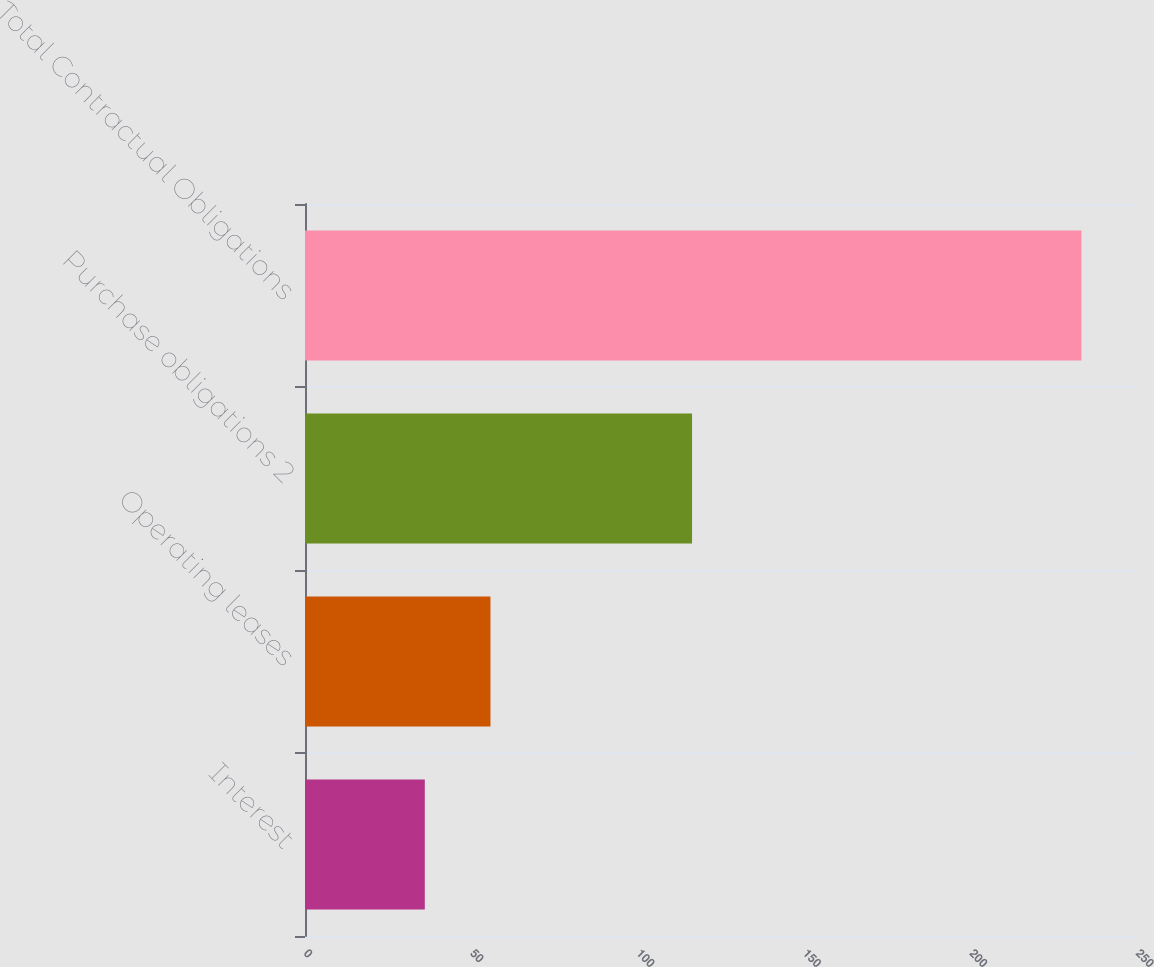Convert chart. <chart><loc_0><loc_0><loc_500><loc_500><bar_chart><fcel>Interest<fcel>Operating leases<fcel>Purchase obligations 2<fcel>Total Contractual Obligations<nl><fcel>36<fcel>55.73<fcel>116.3<fcel>233.3<nl></chart> 